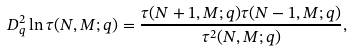<formula> <loc_0><loc_0><loc_500><loc_500>D _ { q } ^ { 2 } \ln \tau ( N , M ; q ) = \frac { \tau ( N + 1 , M ; q ) \tau ( N - 1 , M ; q ) } { \tau ^ { 2 } ( N , M ; q ) } ,</formula> 